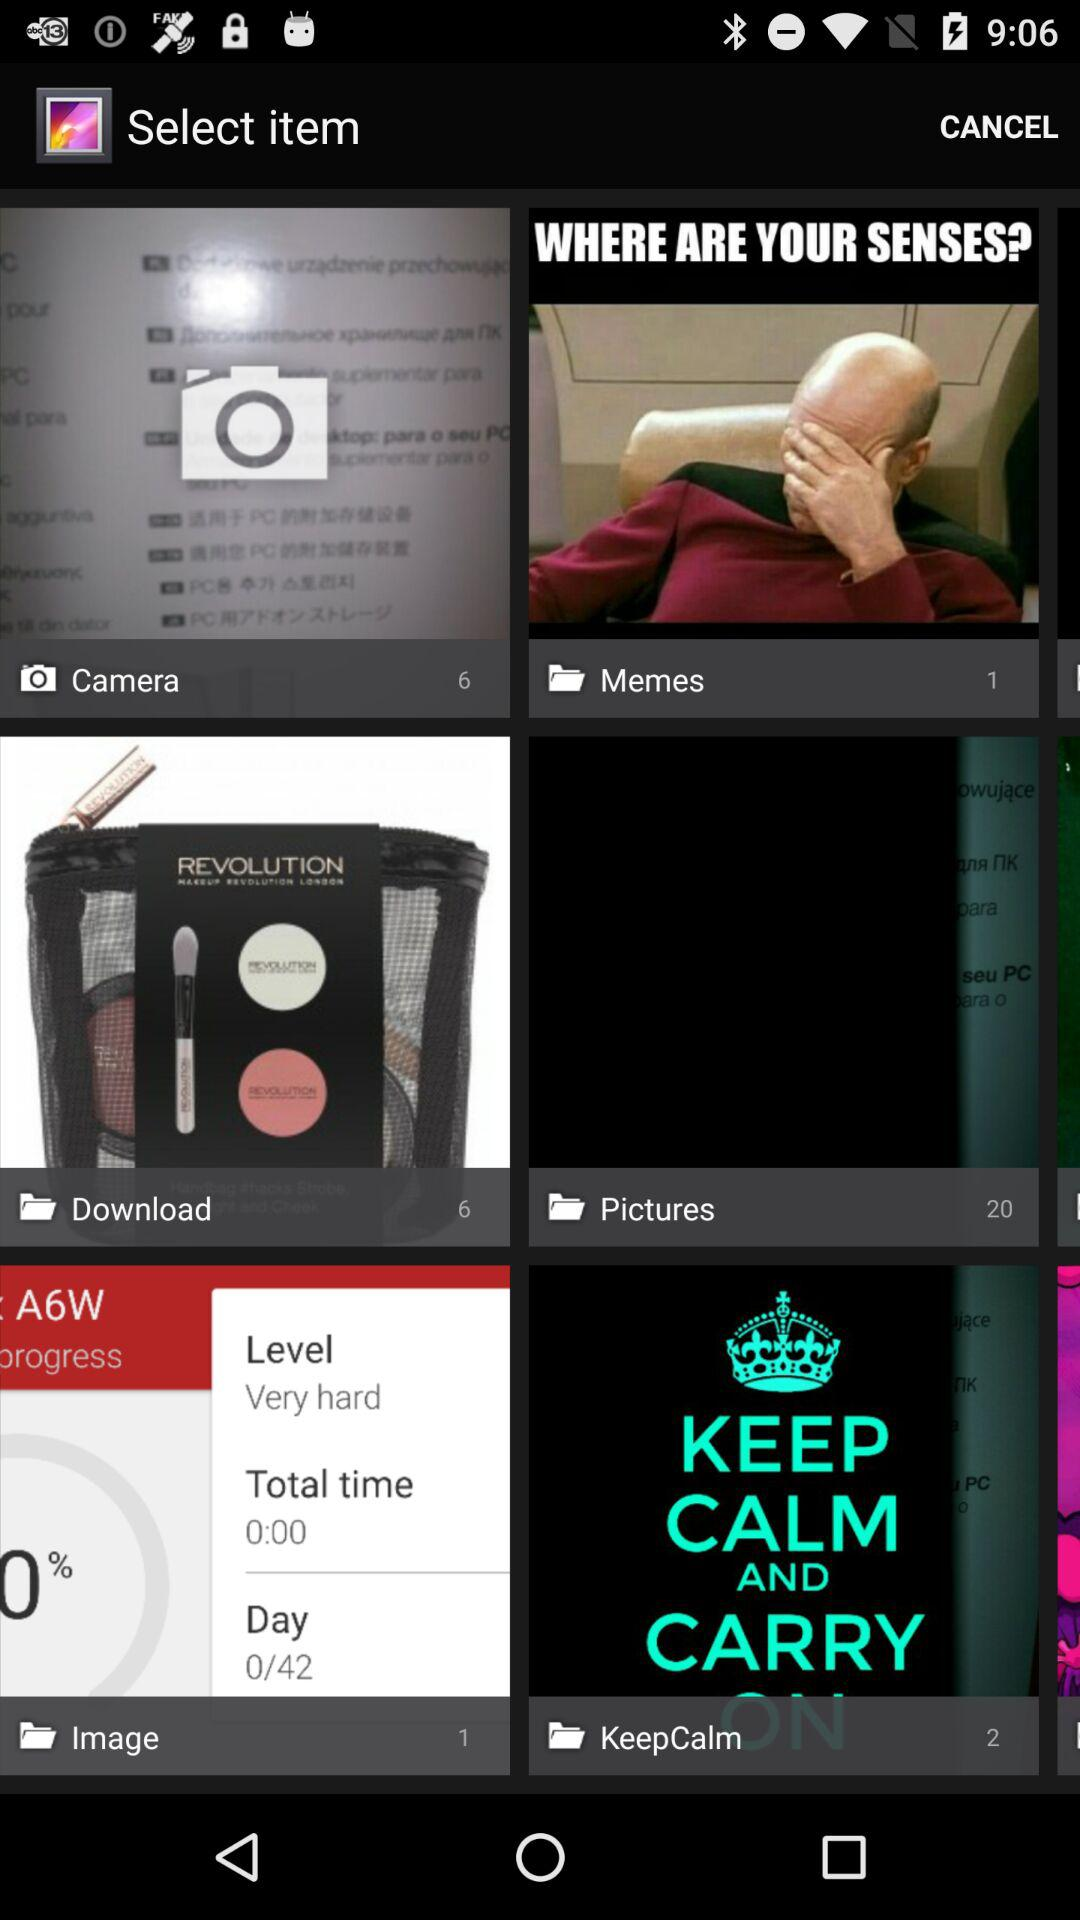When was the "Memes" file uploaded?
When the provided information is insufficient, respond with <no answer>. <no answer> 